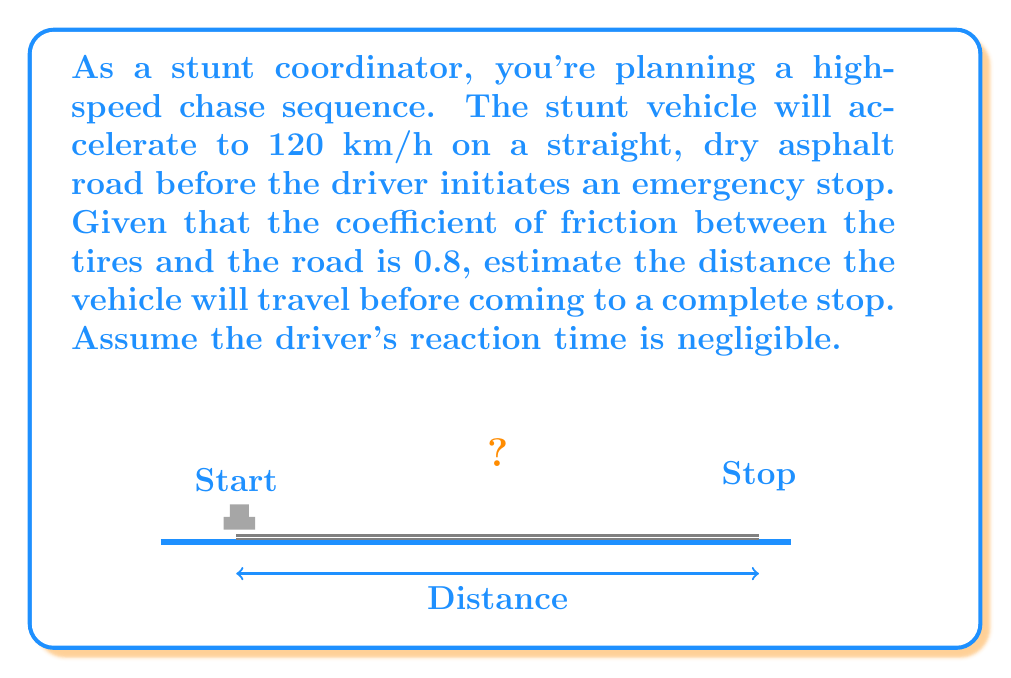Can you answer this question? To solve this problem, we'll use the concept of work-energy theorem and the equation for kinetic energy. Here's a step-by-step solution:

1) First, let's convert the initial velocity from km/h to m/s:
   $$120 \frac{km}{h} = 120 * \frac{1000}{3600} = 33.33 \frac{m}{s}$$

2) The work-energy theorem states that the work done by friction equals the change in kinetic energy:
   $$W_f = \Delta KE$$

3) The work done by friction is the product of the friction force and the distance traveled:
   $$W_f = F_f * d$$

4) The friction force is the product of the normal force and the coefficient of friction:
   $$F_f = \mu * N = \mu * m * g$$

5) The change in kinetic energy is the difference between the initial and final kinetic energy:
   $$\Delta KE = KE_f - KE_i = 0 - \frac{1}{2}mv^2 = -\frac{1}{2}mv^2$$

6) Substituting these into the work-energy equation:
   $$\mu * m * g * d = -\frac{1}{2}mv^2$$

7) The mass (m) cancels out on both sides:
   $$\mu * g * d = -\frac{1}{2}v^2$$

8) Solving for d:
   $$d = \frac{v^2}{2\mu g}$$

9) Now we can substitute our known values:
   $$d = \frac{(33.33)^2}{2 * 0.8 * 9.8} = 70.92 \text{ meters}$$

Therefore, the vehicle will travel approximately 70.92 meters before coming to a complete stop.
Answer: 70.92 meters 